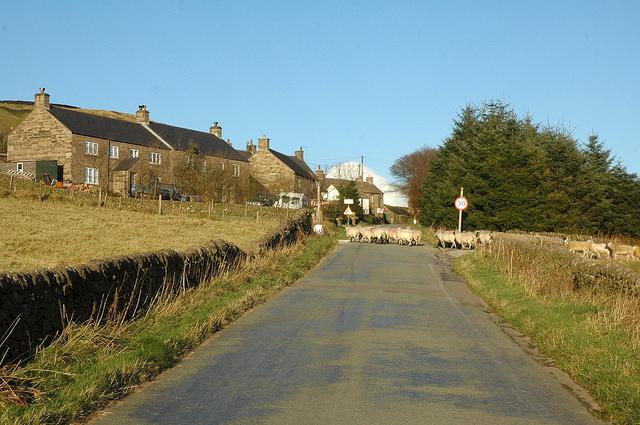What animals are in the picture?
Quick response, please. Sheep. Is this scene in America?
Write a very short answer. No. How many houses are there?
Concise answer only. 4. 